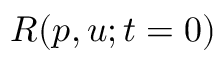<formula> <loc_0><loc_0><loc_500><loc_500>R ( p , u ; t = 0 )</formula> 